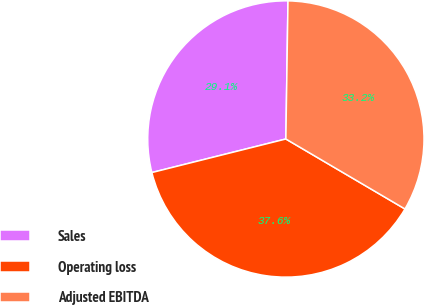Convert chart to OTSL. <chart><loc_0><loc_0><loc_500><loc_500><pie_chart><fcel>Sales<fcel>Operating loss<fcel>Adjusted EBITDA<nl><fcel>29.15%<fcel>37.64%<fcel>33.21%<nl></chart> 